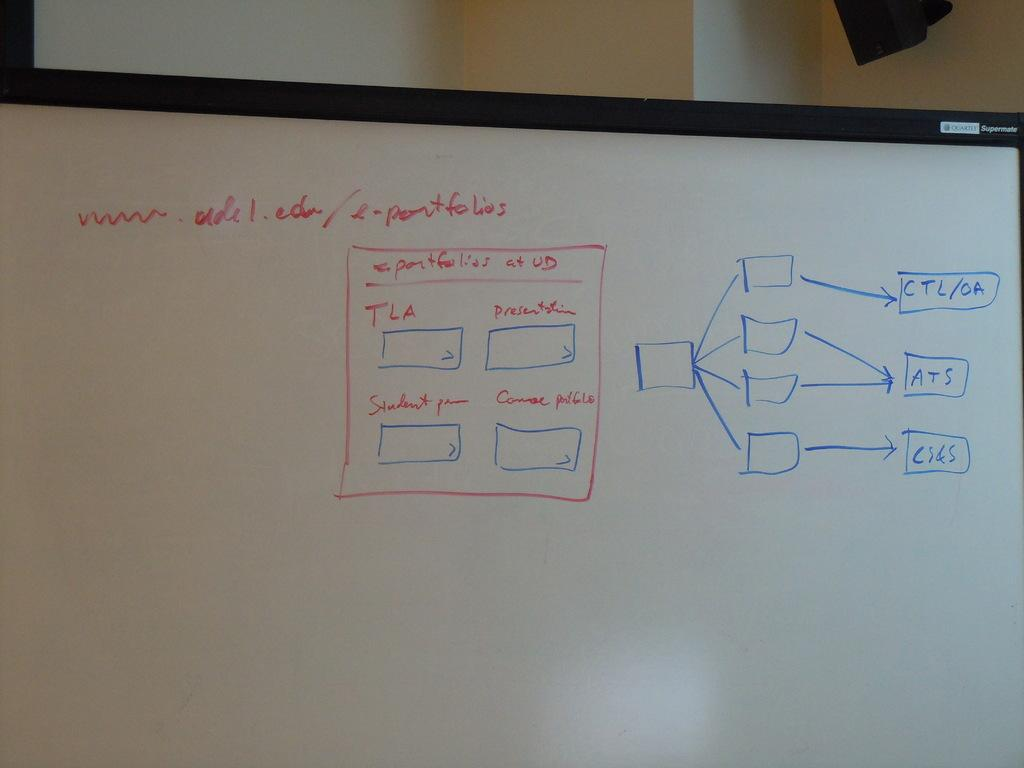<image>
Give a short and clear explanation of the subsequent image. "Portfolios" are explained with a diagram on a white board. 